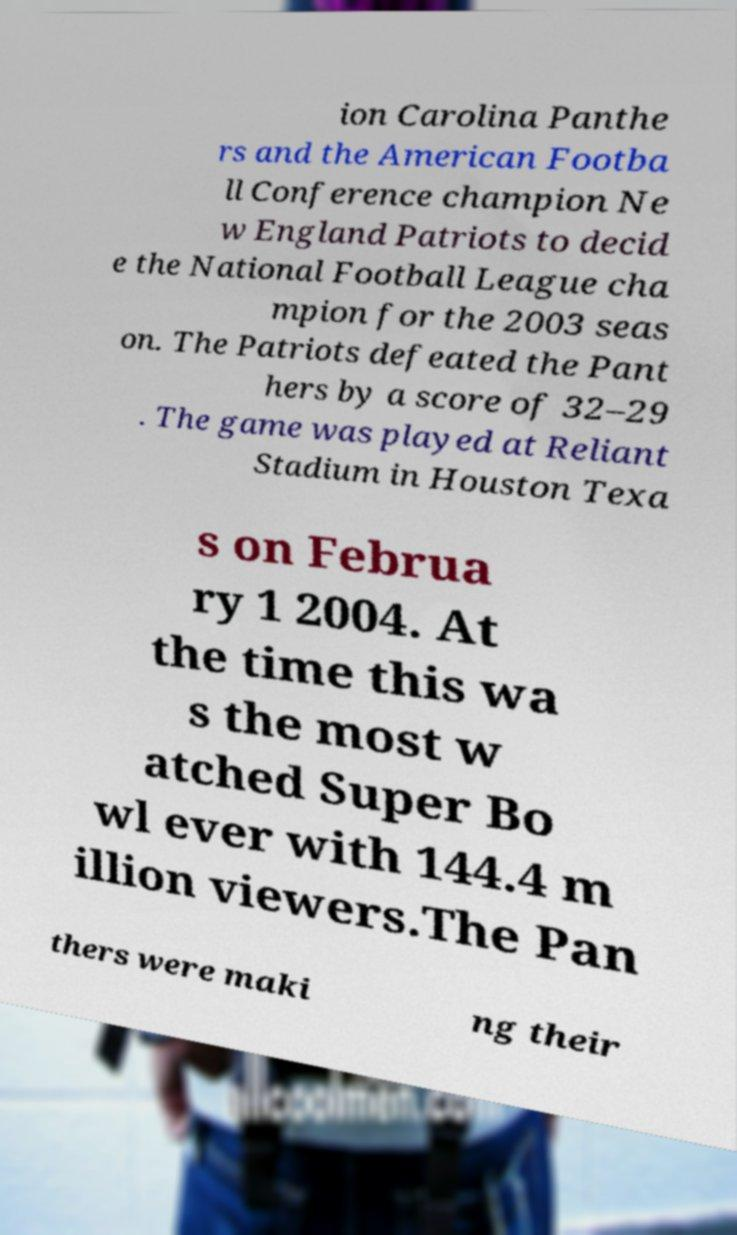Please read and relay the text visible in this image. What does it say? ion Carolina Panthe rs and the American Footba ll Conference champion Ne w England Patriots to decid e the National Football League cha mpion for the 2003 seas on. The Patriots defeated the Pant hers by a score of 32–29 . The game was played at Reliant Stadium in Houston Texa s on Februa ry 1 2004. At the time this wa s the most w atched Super Bo wl ever with 144.4 m illion viewers.The Pan thers were maki ng their 